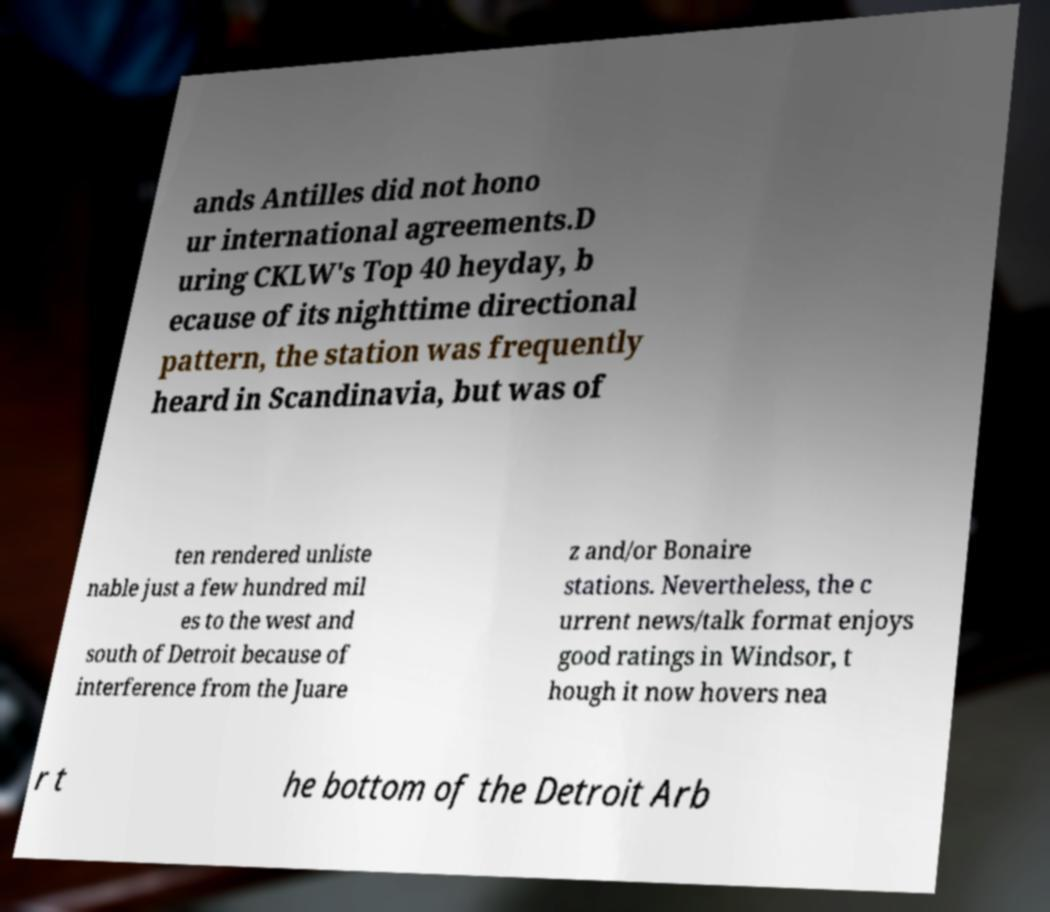I need the written content from this picture converted into text. Can you do that? ands Antilles did not hono ur international agreements.D uring CKLW's Top 40 heyday, b ecause of its nighttime directional pattern, the station was frequently heard in Scandinavia, but was of ten rendered unliste nable just a few hundred mil es to the west and south of Detroit because of interference from the Juare z and/or Bonaire stations. Nevertheless, the c urrent news/talk format enjoys good ratings in Windsor, t hough it now hovers nea r t he bottom of the Detroit Arb 